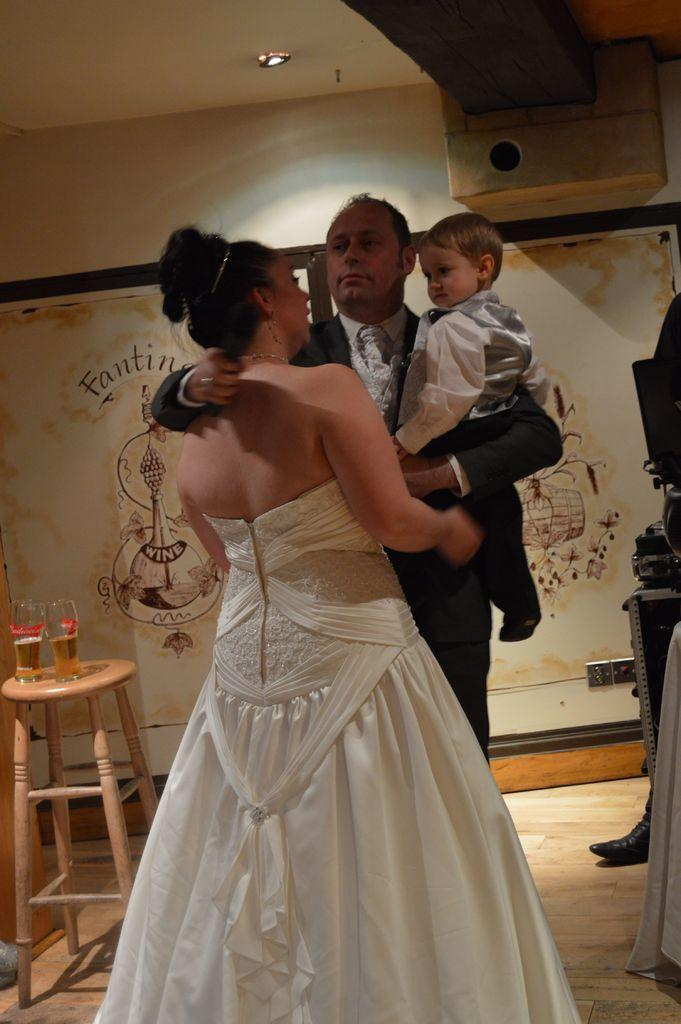How many people are present in the image? There are two people, a man and a woman, present in the image. What is the man holding in the image? The man is holding a boy in the image. What is on the table in the image? There are two wine glasses on the table in the image. What might the man, woman, and boy be doing together? They might be spending time together, possibly at a gathering or event. What type of tin can be seen in the image? There is no tin present in the image. How does the taste of the wine in the glasses compare to the taste of the airplane in the image? There is no airplane present in the image, so it is not possible to compare the taste of the wine to the taste of an airplane. 